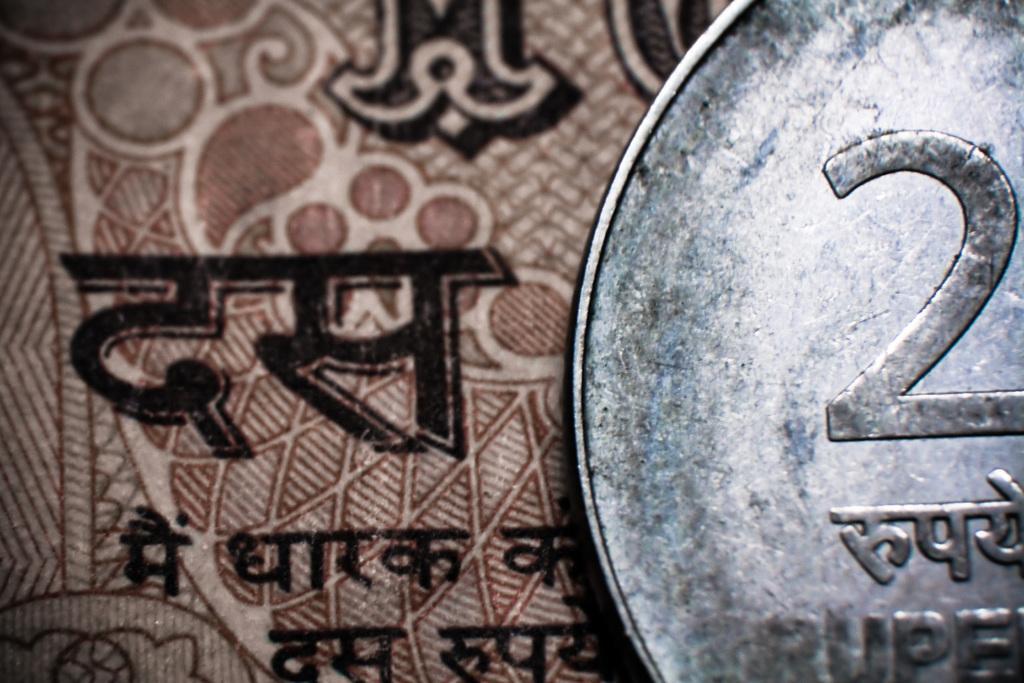In one or two sentences, can you explain what this image depicts? In the image we can see there is a silver coin and a paper. On the paper matter is written in hindi and there is number ¨2¨ on the silver coin. 